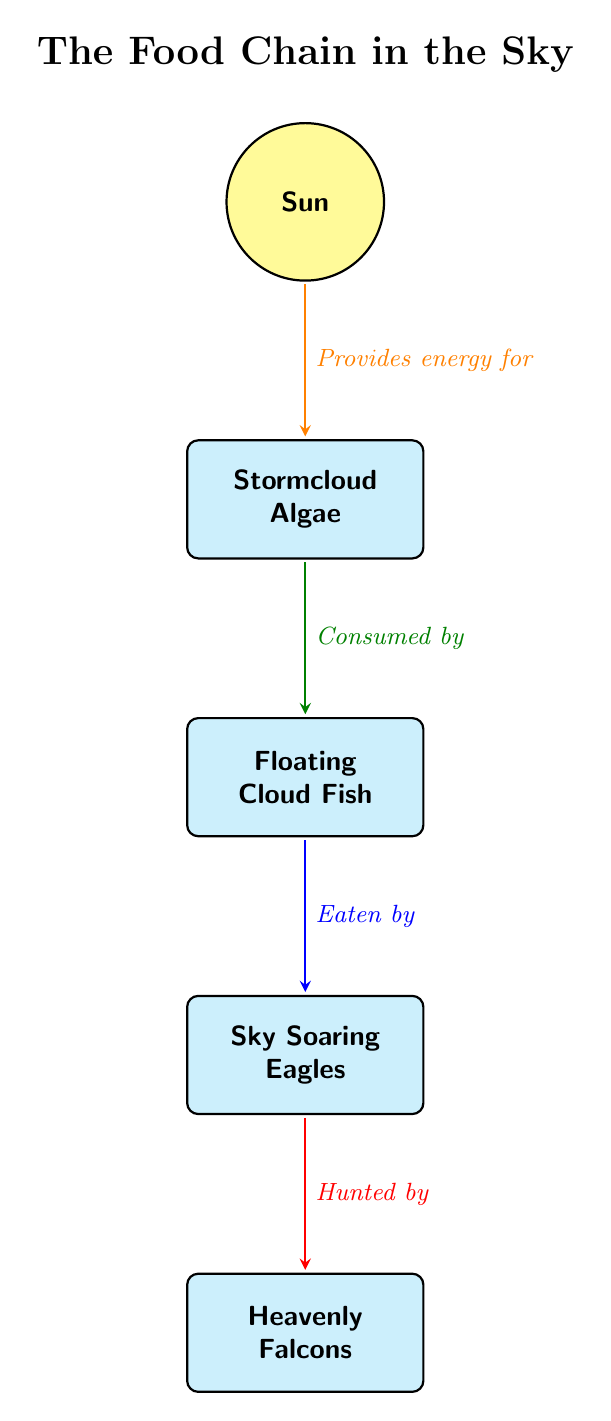What is the energy source in this food chain? The topmost node in the diagram is labeled "Sun," which is indicated as the energy source for the food chain.
Answer: Sun How many levels are there in the food chain? The diagram consists of five nodes arranged vertically, indicating five levels in the food chain.
Answer: 5 What is consumed by Floating Cloud Fish? The arrow directed from "Stormcloud Algae" to "Floating Cloud Fish" shows that the algae are consumed by the fish.
Answer: Stormcloud Algae Who are the hunters of Sky Soaring Eagles? The arrow pointing from "Sky Soaring Eagles" to "Heavenly Falcons" indicates that the falcons are the ones that hunt the eagles.
Answer: Heavenly Falcons What role do fish play in the food chain? "Floating Cloud Fish" is illustrated as being eaten by "Sky Soaring Eagles," signifying that fish play the role of prey in the food chain.
Answer: Prey If Stormcloud Algae provides energy for the food chain, what do the Eagles consume? The flow of the food chain shows that "Sky Soaring Eagles" consume "Floating Cloud Fish," which are fed by "Stormcloud Algae," linking them back to the energy source.
Answer: Floating Cloud Fish How many connections are there in total between the nodes? The diagram has four arrows representing the connections between five nodes, indicating that there are four edges in total.
Answer: 4 What kind of creatures are on the top of the food chain? The diagram positions "Heavenly Falcons" at the topmost spot, which designates them as the apex predators of this food chain.
Answer: Heavenly Falcons What is the immediate next level after Stormcloud Algae? Following the vertical arrangement in the diagram, the node directly below "Stormcloud Algae" is "Floating Cloud Fish."
Answer: Floating Cloud Fish 